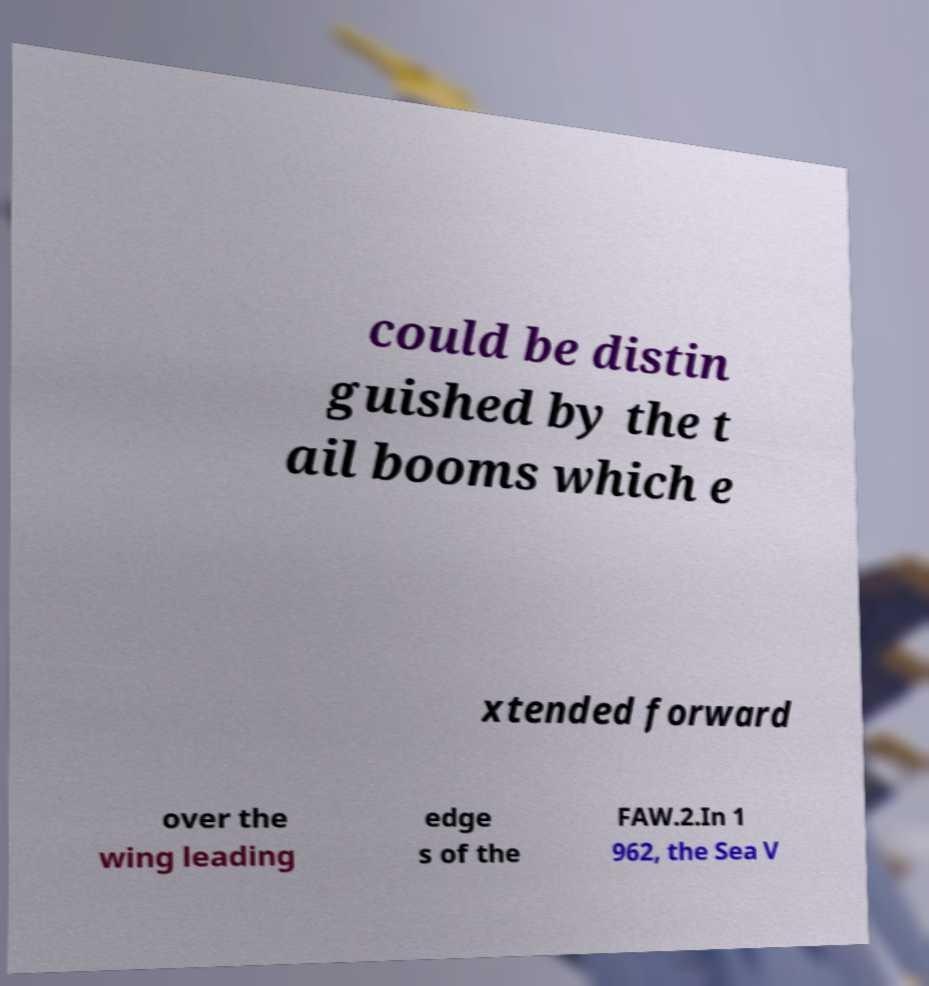There's text embedded in this image that I need extracted. Can you transcribe it verbatim? could be distin guished by the t ail booms which e xtended forward over the wing leading edge s of the FAW.2.In 1 962, the Sea V 